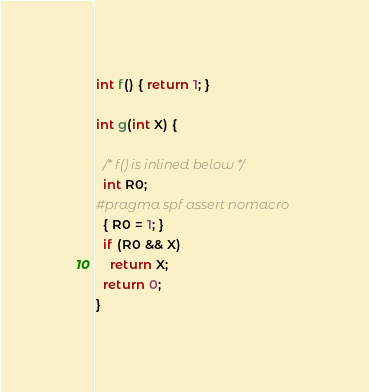Convert code to text. <code><loc_0><loc_0><loc_500><loc_500><_C_>int f() { return 1; }

int g(int X) {

  /* f() is inlined below */
  int R0;
#pragma spf assert nomacro
  { R0 = 1; }
  if (R0 && X)
    return X;
  return 0;
}
</code> 